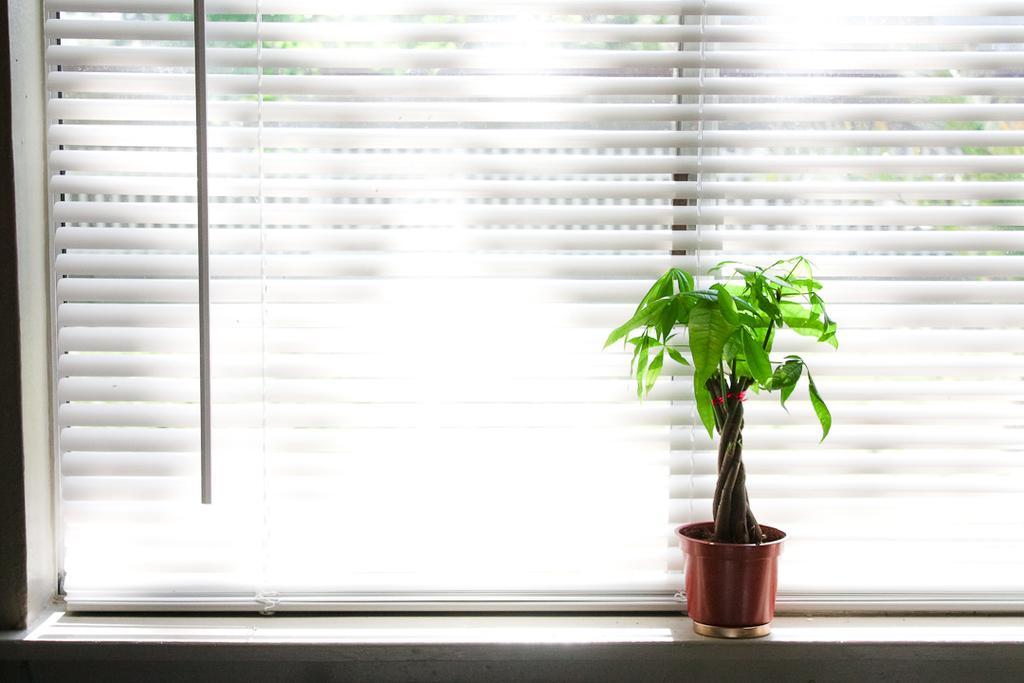In one or two sentences, can you explain what this image depicts? There is a plant. Behind that there is a window blind. 